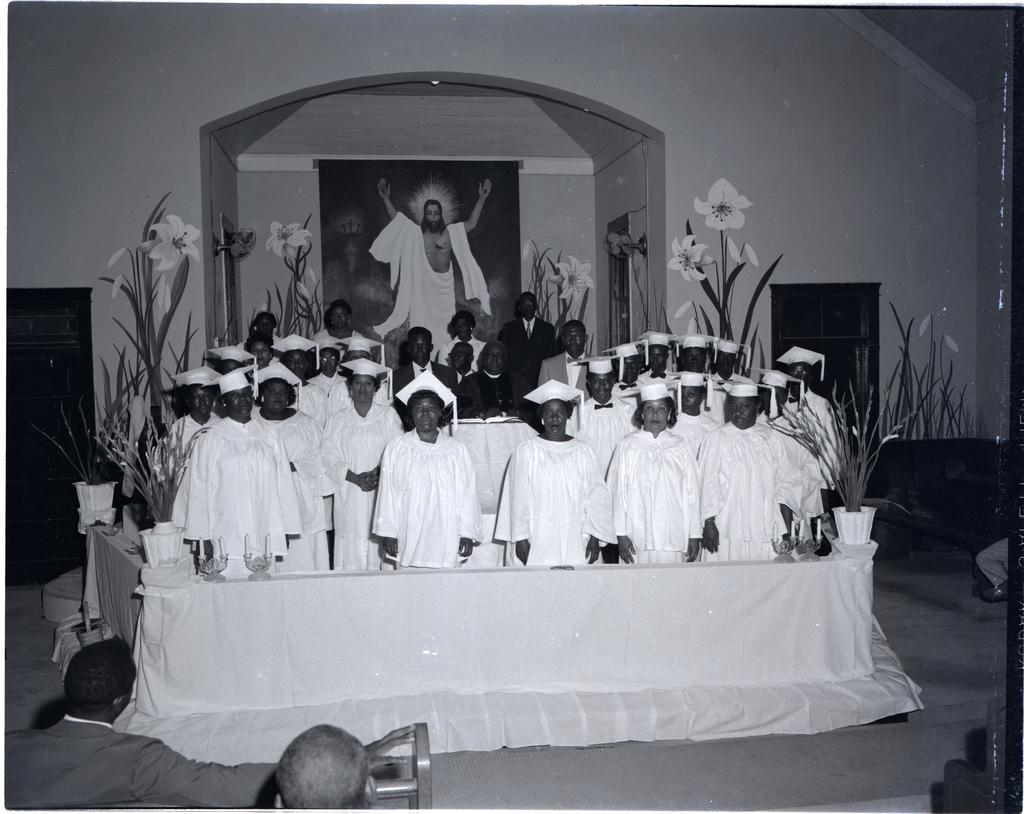Can you describe this image briefly? In front of the image there are two people sitting. In front of them there are a few people standing. Around them there are flower pots on the platform. On both right and left side of the image there are wooden racks. In the background of the image there is a poster on the wall. 